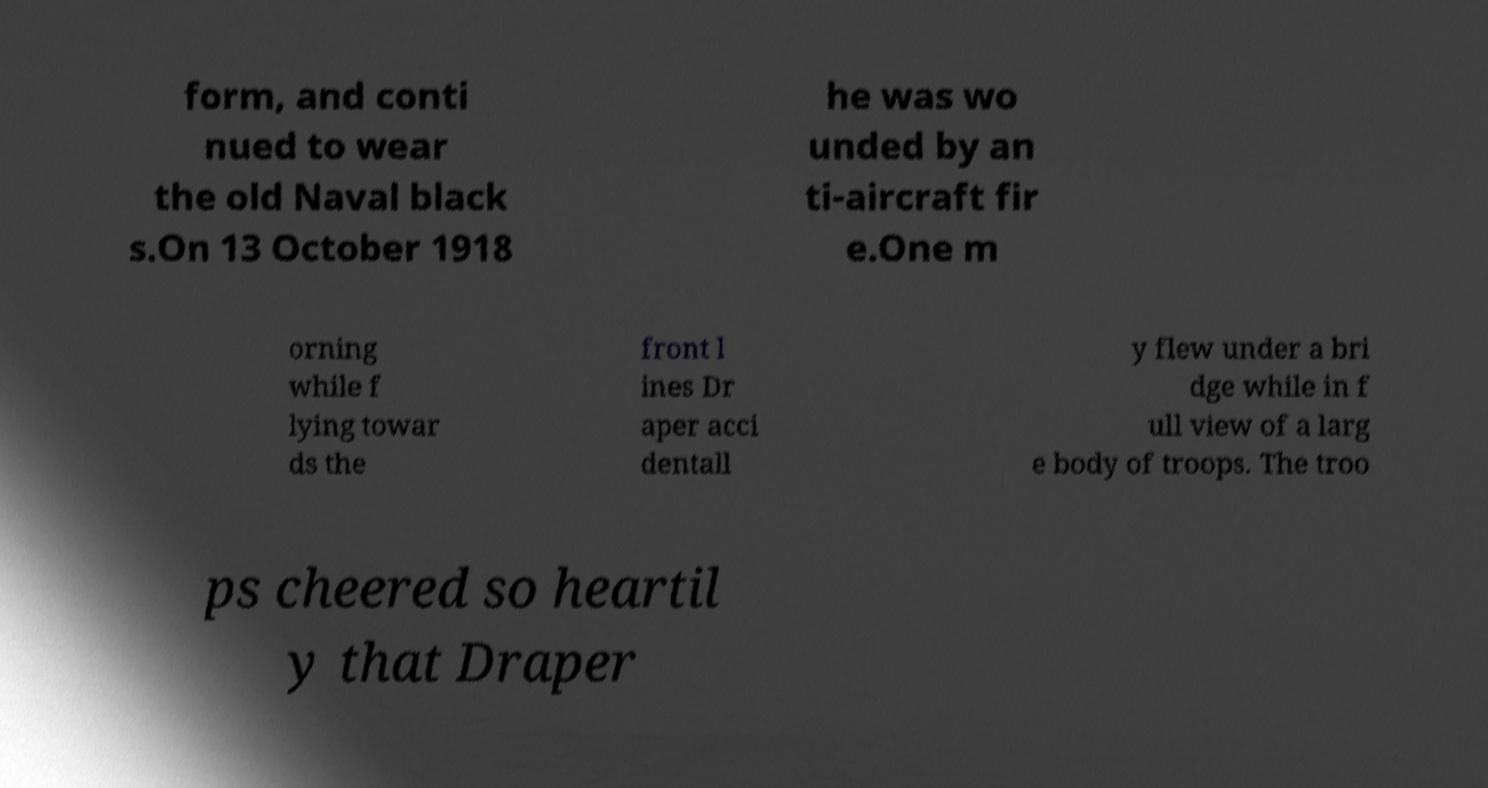Can you accurately transcribe the text from the provided image for me? form, and conti nued to wear the old Naval black s.On 13 October 1918 he was wo unded by an ti-aircraft fir e.One m orning while f lying towar ds the front l ines Dr aper acci dentall y flew under a bri dge while in f ull view of a larg e body of troops. The troo ps cheered so heartil y that Draper 